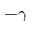<formula> <loc_0><loc_0><loc_500><loc_500>- \gamma</formula> 